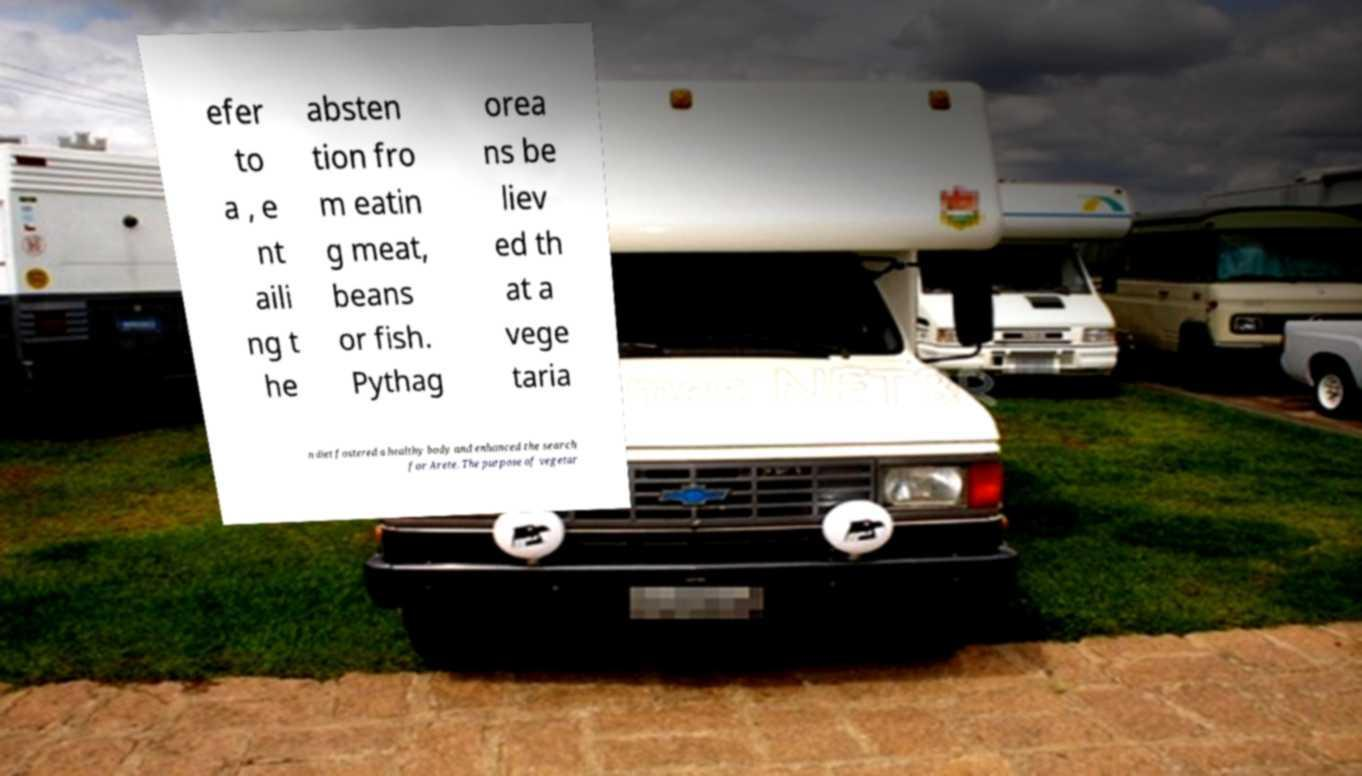Please identify and transcribe the text found in this image. efer to a , e nt aili ng t he absten tion fro m eatin g meat, beans or fish. Pythag orea ns be liev ed th at a vege taria n diet fostered a healthy body and enhanced the search for Arete. The purpose of vegetar 